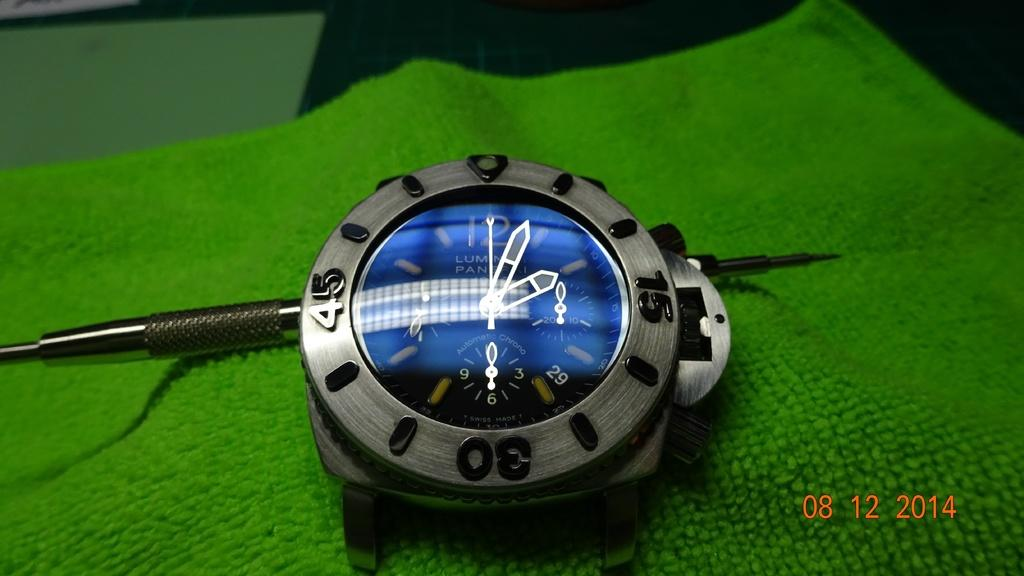Provide a one-sentence caption for the provided image. A picture of a watch taken in 2014 sits on a green cloth. 